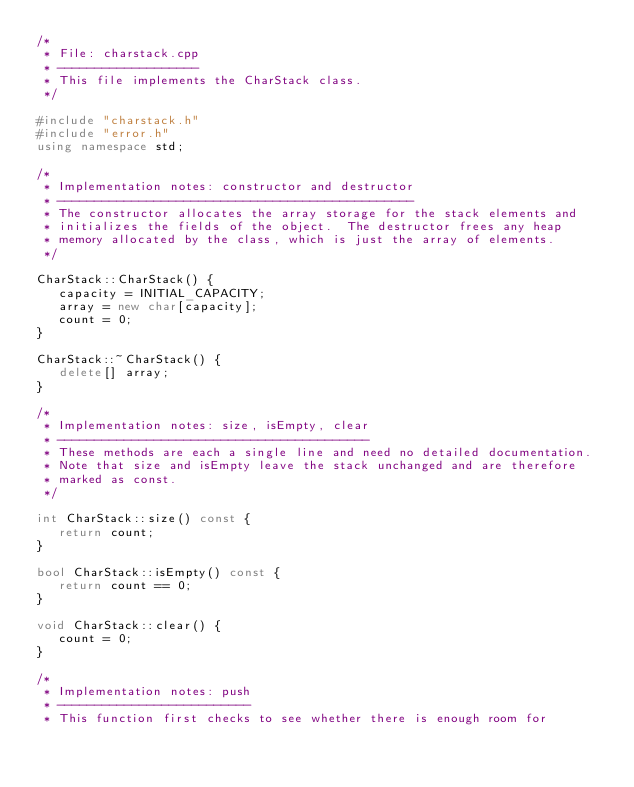<code> <loc_0><loc_0><loc_500><loc_500><_C++_>/*
 * File: charstack.cpp
 * -------------------
 * This file implements the CharStack class.
 */

#include "charstack.h"
#include "error.h"
using namespace std;

/*
 * Implementation notes: constructor and destructor
 * ------------------------------------------------
 * The constructor allocates the array storage for the stack elements and
 * initializes the fields of the object.  The destructor frees any heap
 * memory allocated by the class, which is just the array of elements.
 */

CharStack::CharStack() {
   capacity = INITIAL_CAPACITY;
   array = new char[capacity];
   count = 0;
}

CharStack::~CharStack() {
   delete[] array;
}

/*
 * Implementation notes: size, isEmpty, clear
 * ------------------------------------------
 * These methods are each a single line and need no detailed documentation.
 * Note that size and isEmpty leave the stack unchanged and are therefore
 * marked as const.
 */

int CharStack::size() const {
   return count;
}

bool CharStack::isEmpty() const {
   return count == 0;
}

void CharStack::clear() {
   count = 0;
}

/*
 * Implementation notes: push
 * --------------------------
 * This function first checks to see whether there is enough room for</code> 